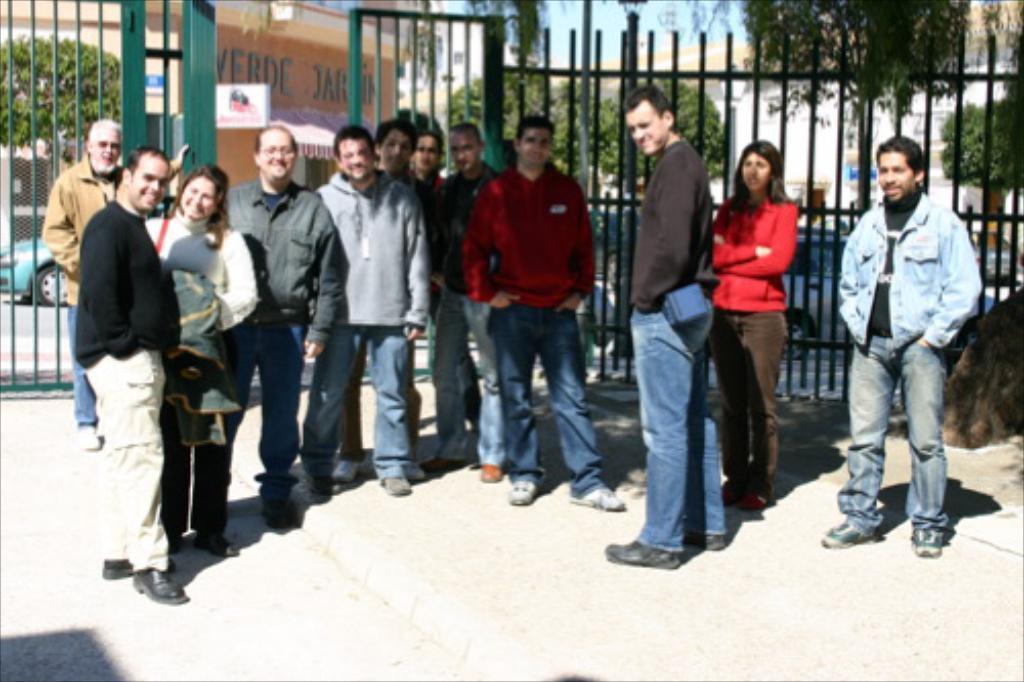How would you summarize this image in a sentence or two? In this picture I can see group of people standing, there are iron grilles, vehicles, there is a house and there are trees. 